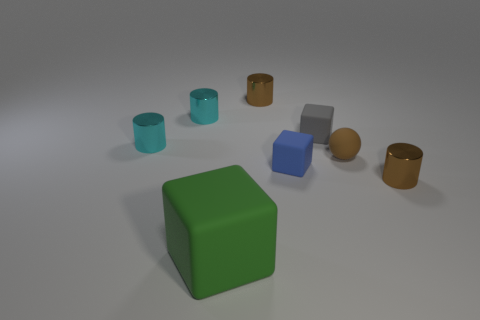Add 2 large blue spheres. How many objects exist? 10 Subtract all spheres. How many objects are left? 7 Add 6 tiny cyan metal objects. How many tiny cyan metal objects exist? 8 Subtract 0 blue cylinders. How many objects are left? 8 Subtract all rubber spheres. Subtract all small matte balls. How many objects are left? 6 Add 3 tiny brown metallic cylinders. How many tiny brown metallic cylinders are left? 5 